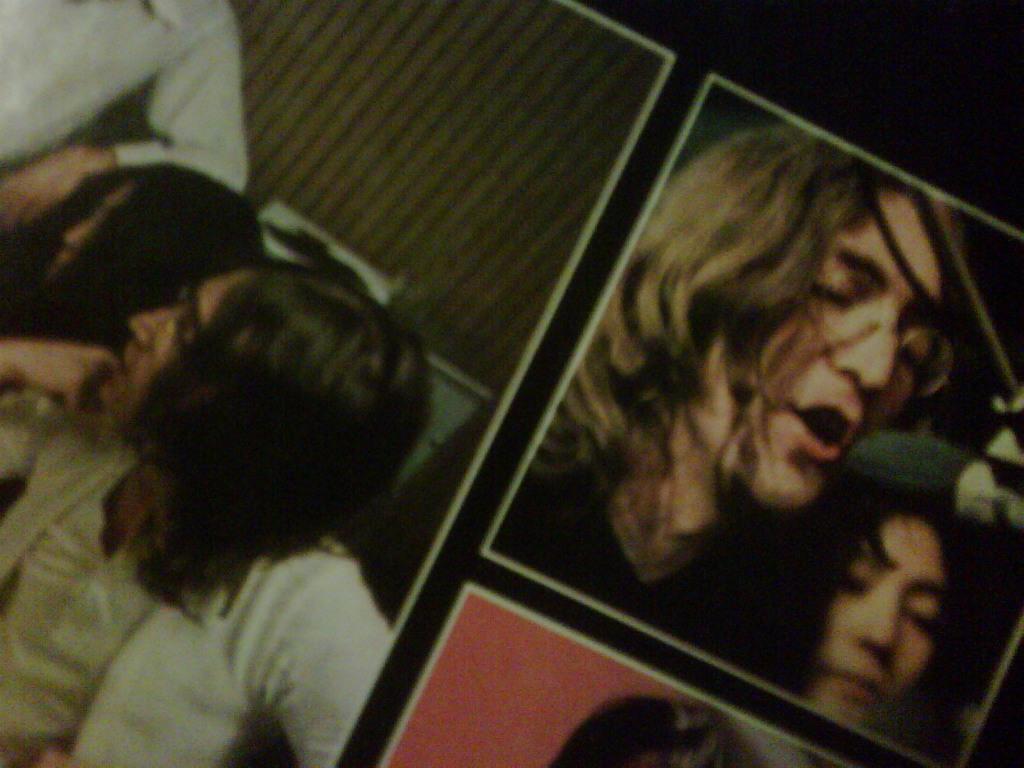Can you describe this image briefly? This is a collage image. In this image I can see people and some other things. The background of the image is dark. 